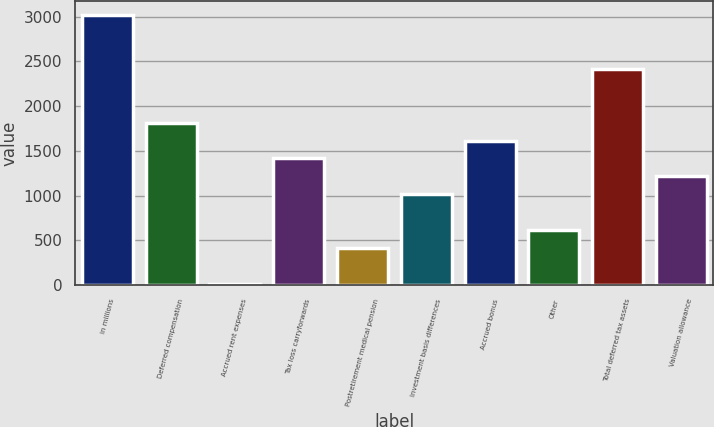Convert chart to OTSL. <chart><loc_0><loc_0><loc_500><loc_500><bar_chart><fcel>in millions<fcel>Deferred compensation<fcel>Accrued rent expenses<fcel>Tax loss carryforwards<fcel>Postretirement medical pension<fcel>Investment basis differences<fcel>Accrued bonus<fcel>Other<fcel>Total deferred tax assets<fcel>Valuation allowance<nl><fcel>3017.85<fcel>1815.63<fcel>12.3<fcel>1414.89<fcel>413.04<fcel>1014.15<fcel>1615.26<fcel>613.41<fcel>2416.74<fcel>1214.52<nl></chart> 